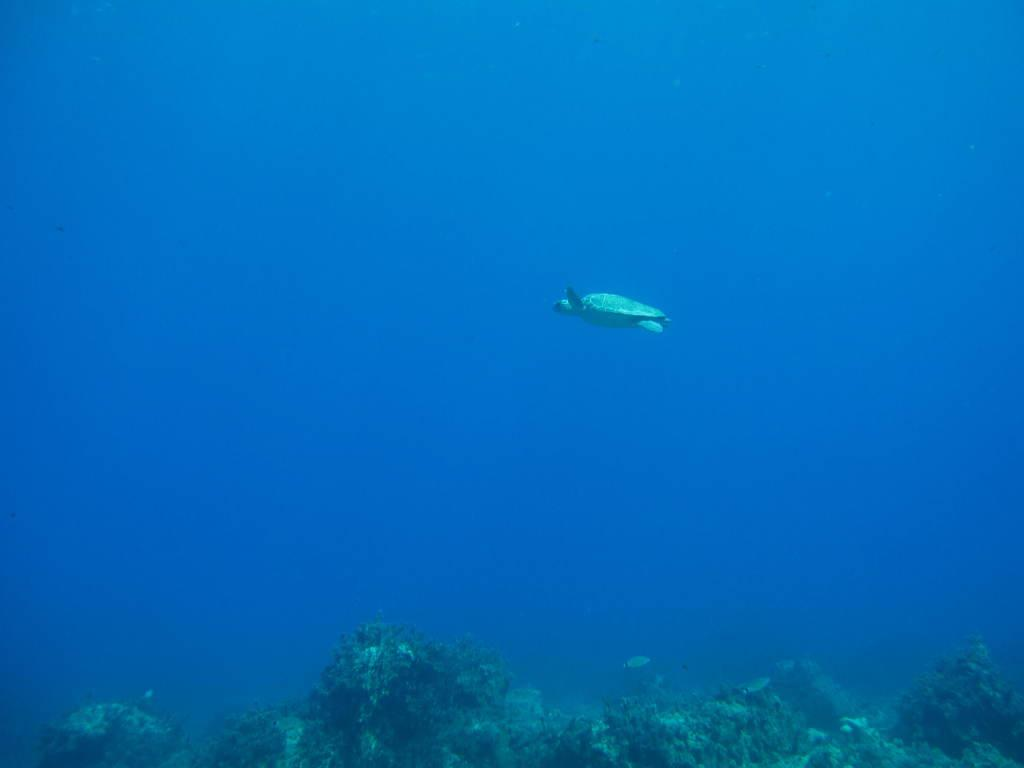Where was the image taken? The image is taken inside the water. What can be seen in the middle of the image? There is a tortoise in the middle of the image. What is visible at the bottom of the image? There are many plants at the bottom of the image. How far is the range of the screw visible in the image? There is no screw present in the image, so it is not possible to determine its range. 